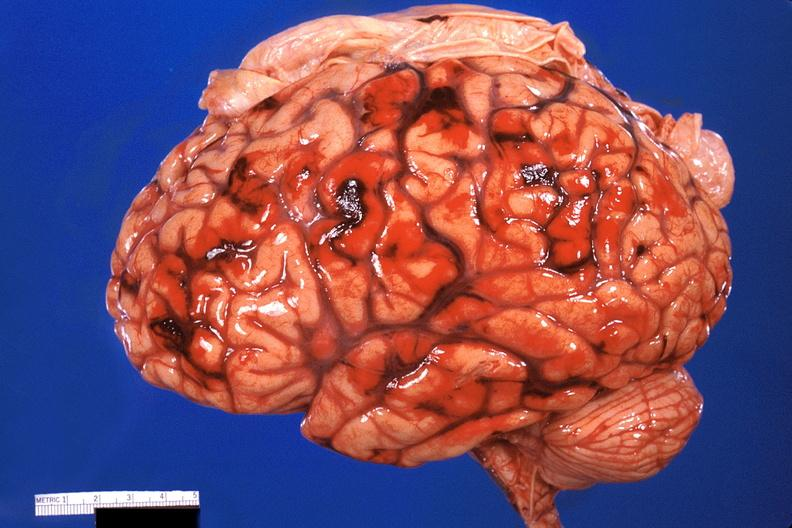why does this image show brain, subarachanoid hemorrhage?
Answer the question using a single word or phrase. Due to disseminated intravascular coagulation 